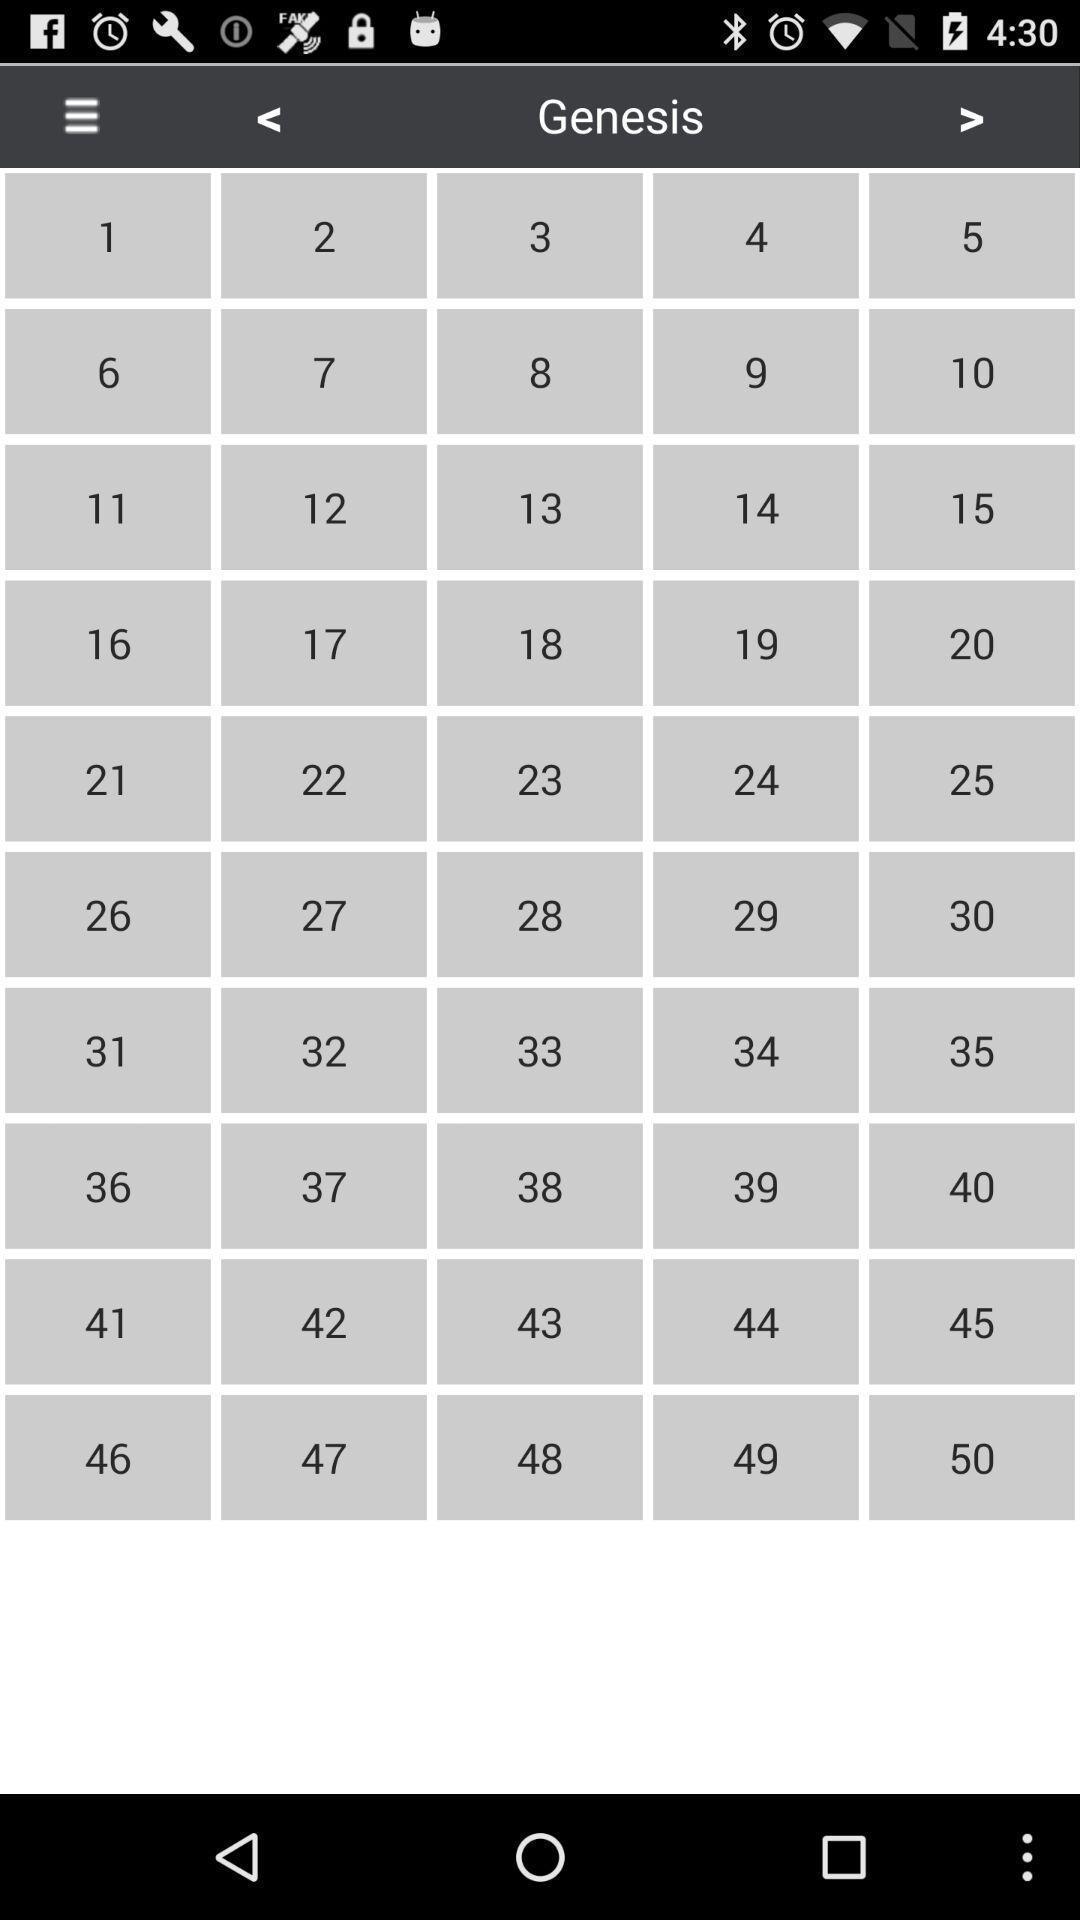Please provide a description for this image. Page displaying the numbers. 